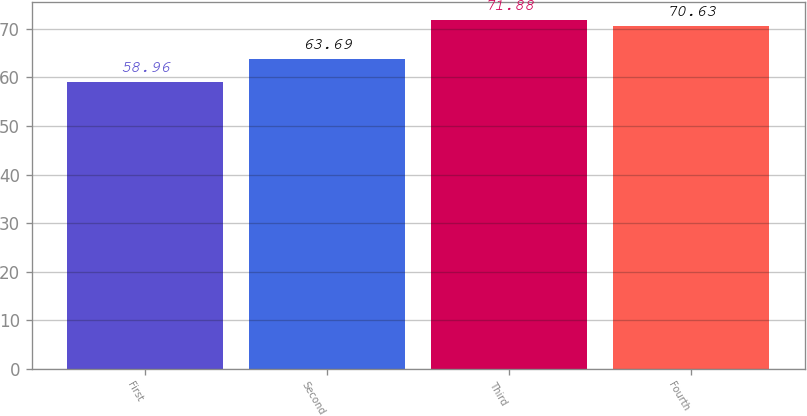<chart> <loc_0><loc_0><loc_500><loc_500><bar_chart><fcel>First<fcel>Second<fcel>Third<fcel>Fourth<nl><fcel>58.96<fcel>63.69<fcel>71.88<fcel>70.63<nl></chart> 